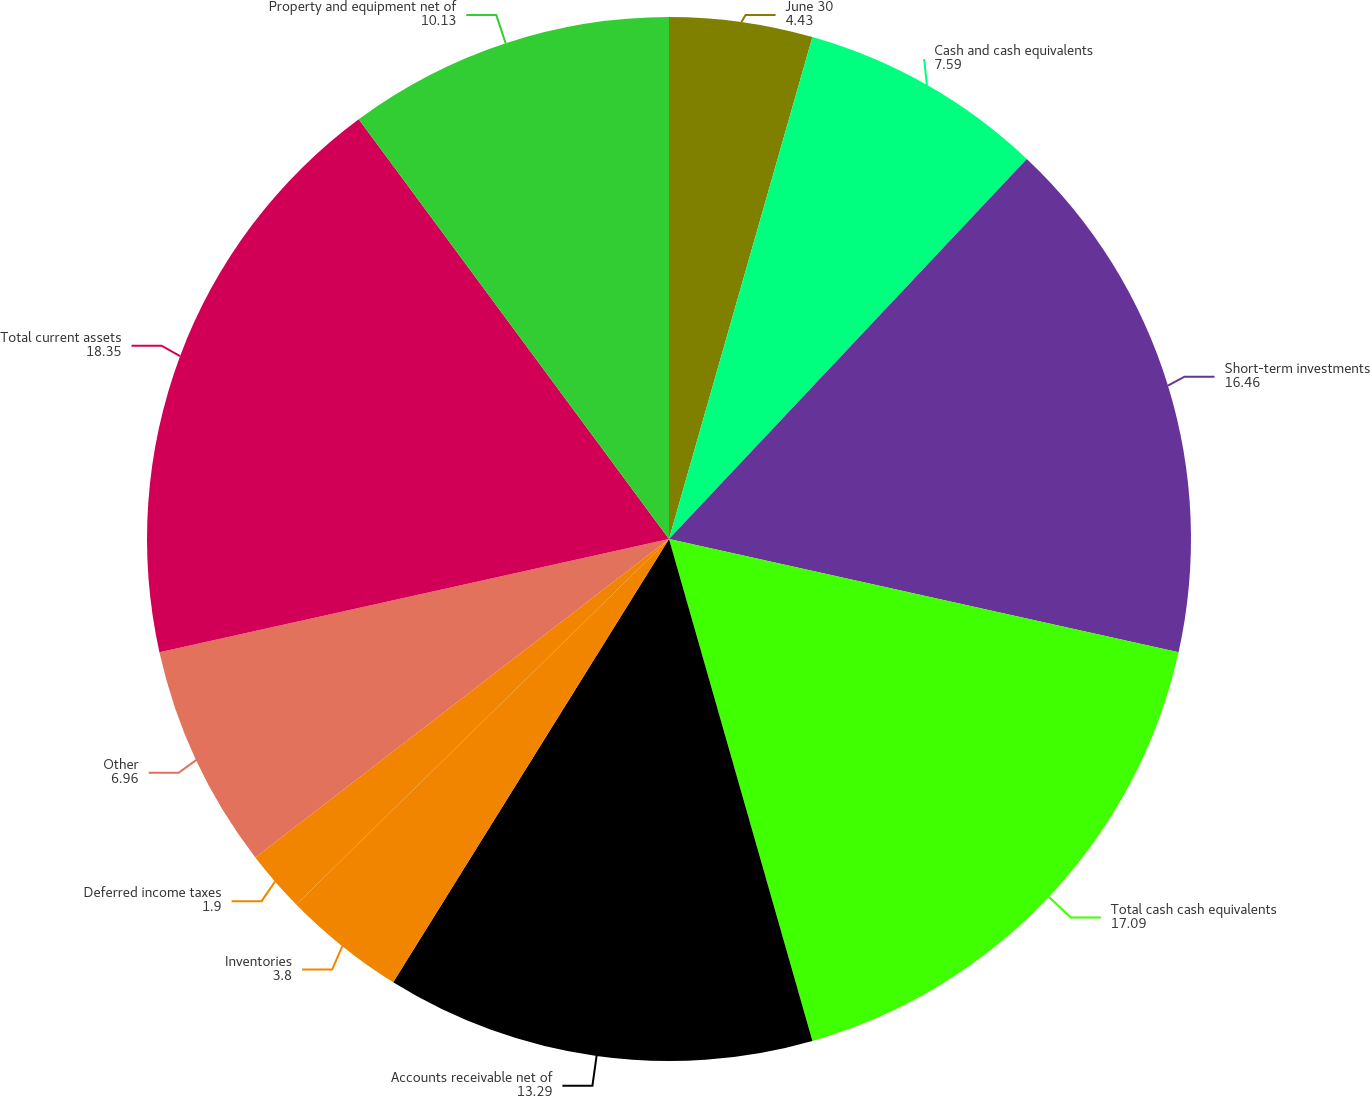<chart> <loc_0><loc_0><loc_500><loc_500><pie_chart><fcel>June 30<fcel>Cash and cash equivalents<fcel>Short-term investments<fcel>Total cash cash equivalents<fcel>Accounts receivable net of<fcel>Inventories<fcel>Deferred income taxes<fcel>Other<fcel>Total current assets<fcel>Property and equipment net of<nl><fcel>4.43%<fcel>7.59%<fcel>16.46%<fcel>17.09%<fcel>13.29%<fcel>3.8%<fcel>1.9%<fcel>6.96%<fcel>18.35%<fcel>10.13%<nl></chart> 